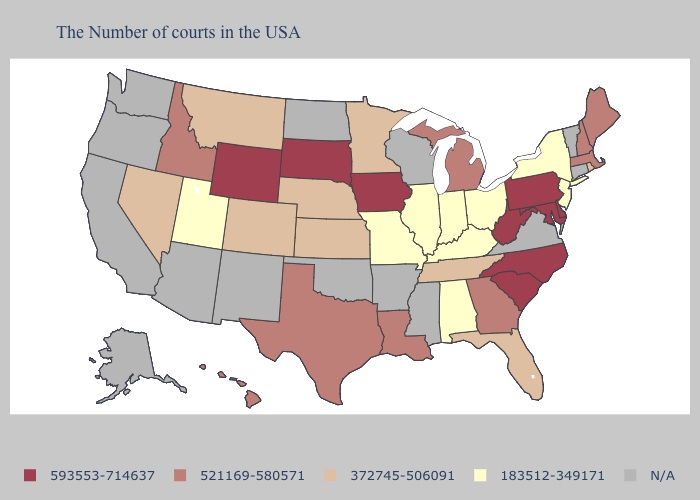What is the value of Florida?
Answer briefly. 372745-506091. What is the lowest value in states that border Vermont?
Concise answer only. 183512-349171. Which states have the lowest value in the West?
Be succinct. Utah. What is the value of Virginia?
Give a very brief answer. N/A. What is the highest value in states that border Washington?
Quick response, please. 521169-580571. Which states have the highest value in the USA?
Short answer required. Delaware, Maryland, Pennsylvania, North Carolina, South Carolina, West Virginia, Iowa, South Dakota, Wyoming. What is the lowest value in the USA?
Concise answer only. 183512-349171. What is the value of New Mexico?
Be succinct. N/A. Which states have the highest value in the USA?
Give a very brief answer. Delaware, Maryland, Pennsylvania, North Carolina, South Carolina, West Virginia, Iowa, South Dakota, Wyoming. Among the states that border Connecticut , which have the highest value?
Short answer required. Massachusetts. What is the lowest value in the USA?
Quick response, please. 183512-349171. What is the highest value in the USA?
Quick response, please. 593553-714637. Which states have the highest value in the USA?
Write a very short answer. Delaware, Maryland, Pennsylvania, North Carolina, South Carolina, West Virginia, Iowa, South Dakota, Wyoming. What is the lowest value in the USA?
Answer briefly. 183512-349171. What is the lowest value in states that border Idaho?
Write a very short answer. 183512-349171. 